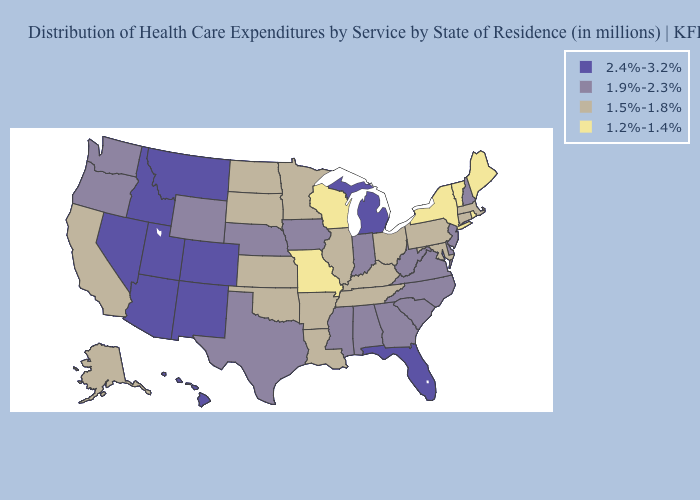What is the lowest value in the West?
Short answer required. 1.5%-1.8%. Among the states that border Kentucky , does Indiana have the highest value?
Keep it brief. Yes. Name the states that have a value in the range 2.4%-3.2%?
Answer briefly. Arizona, Colorado, Florida, Hawaii, Idaho, Michigan, Montana, Nevada, New Mexico, Utah. What is the lowest value in the USA?
Concise answer only. 1.2%-1.4%. Among the states that border Oregon , does California have the lowest value?
Answer briefly. Yes. Which states have the lowest value in the USA?
Write a very short answer. Maine, Missouri, New York, Rhode Island, Vermont, Wisconsin. Does Vermont have the lowest value in the USA?
Short answer required. Yes. What is the value of Arizona?
Write a very short answer. 2.4%-3.2%. Does Minnesota have a lower value than Vermont?
Write a very short answer. No. Which states have the lowest value in the West?
Be succinct. Alaska, California. What is the value of New Mexico?
Be succinct. 2.4%-3.2%. What is the highest value in states that border Washington?
Write a very short answer. 2.4%-3.2%. Name the states that have a value in the range 2.4%-3.2%?
Short answer required. Arizona, Colorado, Florida, Hawaii, Idaho, Michigan, Montana, Nevada, New Mexico, Utah. What is the lowest value in the MidWest?
Write a very short answer. 1.2%-1.4%. Does the map have missing data?
Be succinct. No. 